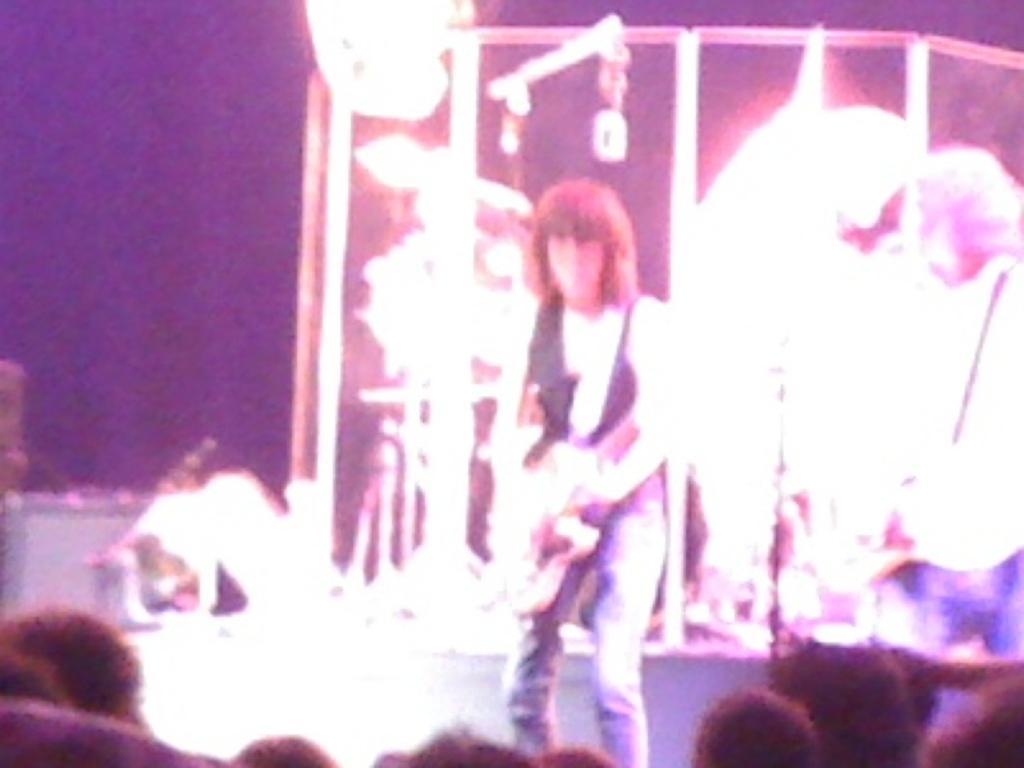What is the main subject of the image? There is a person standing in the image. What are the other people in the image doing? There are audience members sitting in the image. Can you describe the background of the image? The background of the image is blurred. What type of clam is being served to the audience in the image? There is no clam or any food being served in the image; it features a person standing and audience members sitting. What kind of jam is being used to decorate the stage in the image? There is no jam or any decoration on the stage in the image; it only shows a person standing and audience members sitting. 